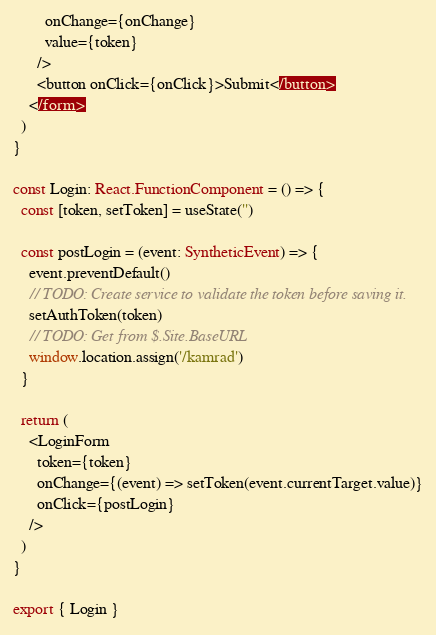<code> <loc_0><loc_0><loc_500><loc_500><_TypeScript_>        onChange={onChange}
        value={token}
      />
      <button onClick={onClick}>Submit</button>
    </form>
  )
}

const Login: React.FunctionComponent = () => {
  const [token, setToken] = useState('')

  const postLogin = (event: SyntheticEvent) => {
    event.preventDefault()
    // TODO: Create service to validate the token before saving it.
    setAuthToken(token)
    // TODO: Get from $.Site.BaseURL
    window.location.assign('/kamrad')
  }

  return (
    <LoginForm
      token={token}
      onChange={(event) => setToken(event.currentTarget.value)}
      onClick={postLogin}
    />
  )
}

export { Login }
</code> 